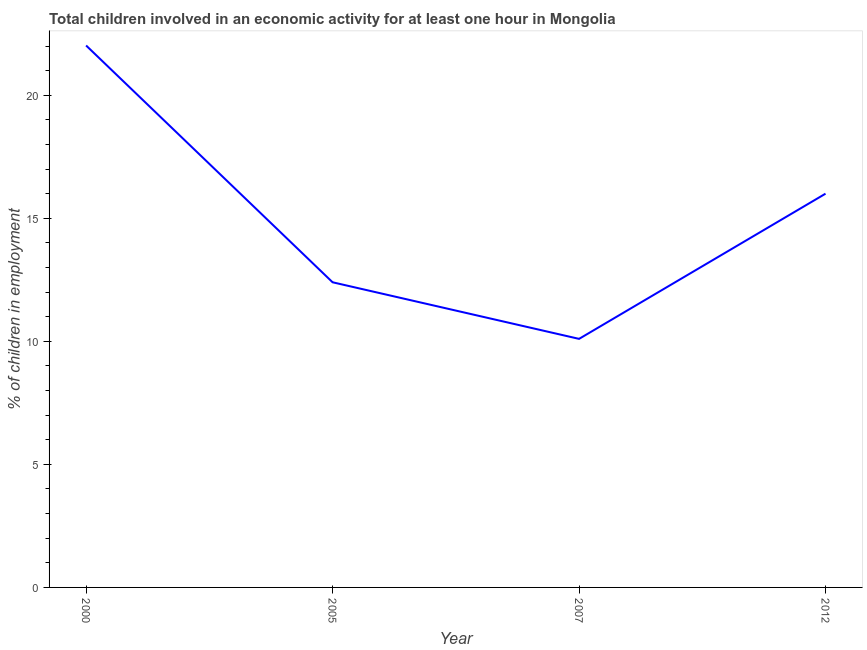Across all years, what is the maximum percentage of children in employment?
Provide a short and direct response. 22.02. Across all years, what is the minimum percentage of children in employment?
Offer a terse response. 10.1. In which year was the percentage of children in employment minimum?
Make the answer very short. 2007. What is the sum of the percentage of children in employment?
Give a very brief answer. 60.52. What is the difference between the percentage of children in employment in 2000 and 2005?
Your response must be concise. 9.62. What is the average percentage of children in employment per year?
Your answer should be very brief. 15.13. Do a majority of the years between 2000 and 2007 (inclusive) have percentage of children in employment greater than 4 %?
Provide a succinct answer. Yes. What is the ratio of the percentage of children in employment in 2007 to that in 2012?
Ensure brevity in your answer.  0.63. What is the difference between the highest and the second highest percentage of children in employment?
Your answer should be very brief. 6.02. Is the sum of the percentage of children in employment in 2005 and 2012 greater than the maximum percentage of children in employment across all years?
Make the answer very short. Yes. What is the difference between the highest and the lowest percentage of children in employment?
Your answer should be very brief. 11.92. How many years are there in the graph?
Keep it short and to the point. 4. What is the difference between two consecutive major ticks on the Y-axis?
Your answer should be very brief. 5. Are the values on the major ticks of Y-axis written in scientific E-notation?
Your answer should be very brief. No. Does the graph contain grids?
Your response must be concise. No. What is the title of the graph?
Make the answer very short. Total children involved in an economic activity for at least one hour in Mongolia. What is the label or title of the Y-axis?
Your answer should be compact. % of children in employment. What is the % of children in employment of 2000?
Make the answer very short. 22.02. What is the % of children in employment of 2007?
Your answer should be very brief. 10.1. What is the difference between the % of children in employment in 2000 and 2005?
Ensure brevity in your answer.  9.62. What is the difference between the % of children in employment in 2000 and 2007?
Your answer should be very brief. 11.92. What is the difference between the % of children in employment in 2000 and 2012?
Provide a succinct answer. 6.02. What is the difference between the % of children in employment in 2005 and 2007?
Provide a short and direct response. 2.3. What is the difference between the % of children in employment in 2005 and 2012?
Offer a terse response. -3.6. What is the ratio of the % of children in employment in 2000 to that in 2005?
Offer a terse response. 1.78. What is the ratio of the % of children in employment in 2000 to that in 2007?
Your answer should be very brief. 2.18. What is the ratio of the % of children in employment in 2000 to that in 2012?
Give a very brief answer. 1.38. What is the ratio of the % of children in employment in 2005 to that in 2007?
Provide a short and direct response. 1.23. What is the ratio of the % of children in employment in 2005 to that in 2012?
Offer a very short reply. 0.78. What is the ratio of the % of children in employment in 2007 to that in 2012?
Offer a very short reply. 0.63. 